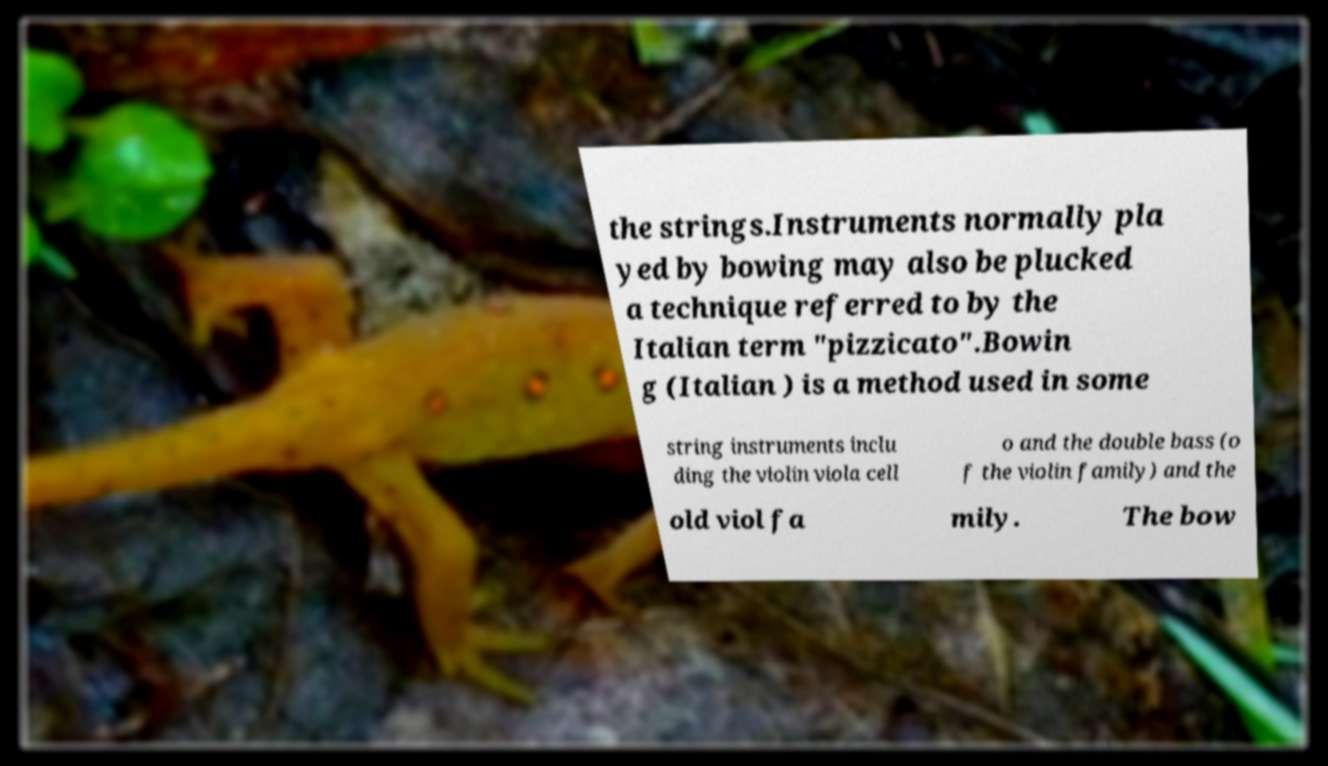For documentation purposes, I need the text within this image transcribed. Could you provide that? the strings.Instruments normally pla yed by bowing may also be plucked a technique referred to by the Italian term "pizzicato".Bowin g (Italian ) is a method used in some string instruments inclu ding the violin viola cell o and the double bass (o f the violin family) and the old viol fa mily. The bow 